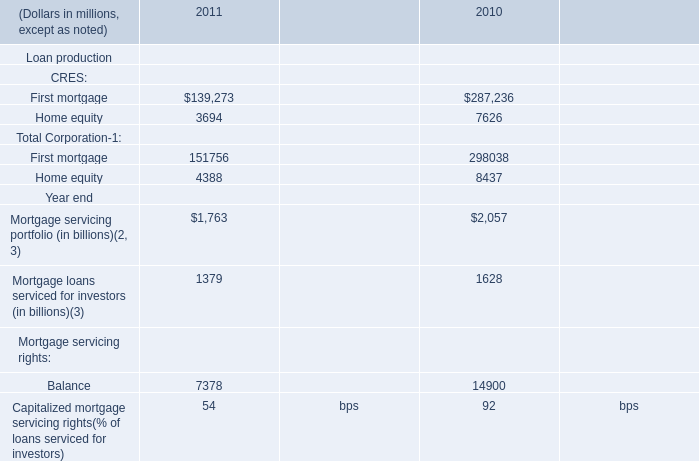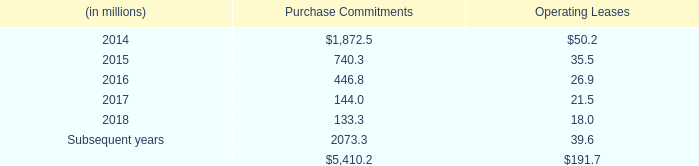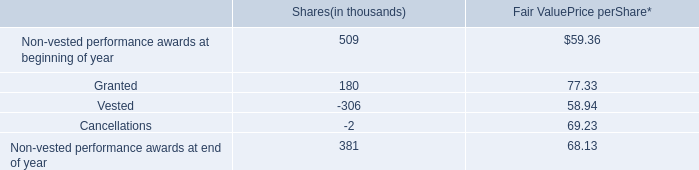what was the percent of the change in the non-vested performance awards at end of year 
Computations: ((381 - 509) / 509)
Answer: -0.25147. 